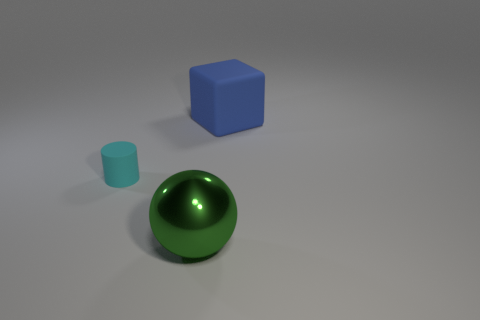Is there anything else that has the same material as the ball?
Offer a terse response. No. Is there any other thing that is the same size as the matte cylinder?
Offer a very short reply. No. How many big green balls are on the right side of the matte thing that is in front of the big thing to the right of the big ball?
Your answer should be very brief. 1. Are there fewer matte things that are to the right of the tiny cyan cylinder than things behind the large green sphere?
Your answer should be very brief. Yes. What number of other objects are there of the same material as the blue block?
Your response must be concise. 1. There is a cube that is the same size as the metal thing; what material is it?
Make the answer very short. Rubber. What number of purple objects are tiny cubes or shiny objects?
Provide a short and direct response. 0. What is the color of the thing that is to the right of the tiny matte cylinder and on the left side of the blue thing?
Make the answer very short. Green. Is the material of the thing on the right side of the big sphere the same as the thing that is in front of the small cyan object?
Offer a very short reply. No. Is the number of tiny cyan rubber cylinders that are on the left side of the metallic object greater than the number of cylinders behind the large rubber block?
Your answer should be very brief. Yes. 